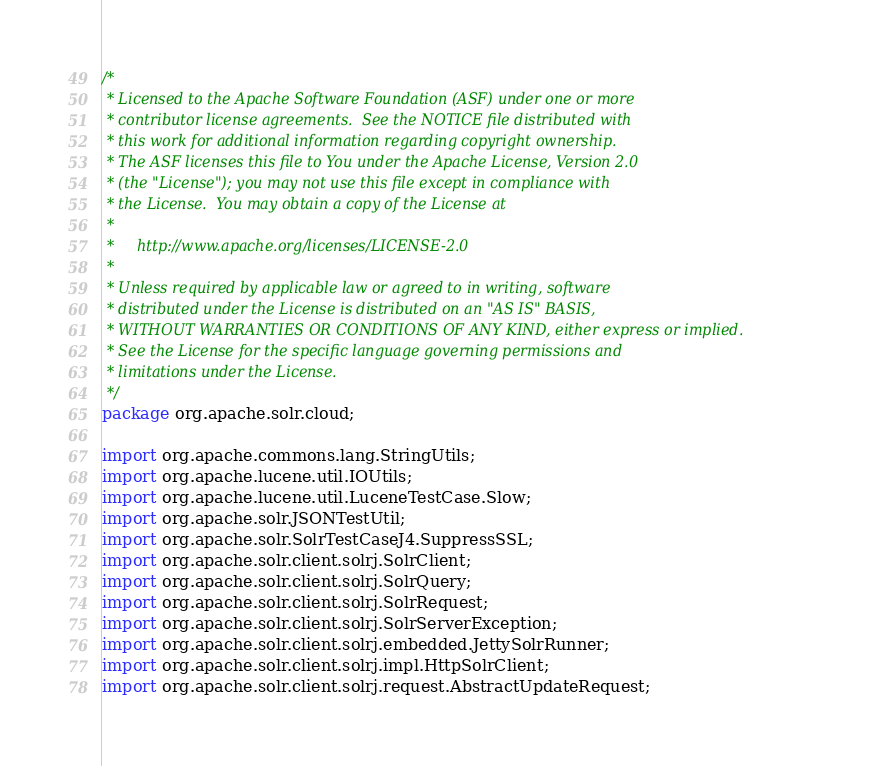<code> <loc_0><loc_0><loc_500><loc_500><_Java_>/*
 * Licensed to the Apache Software Foundation (ASF) under one or more
 * contributor license agreements.  See the NOTICE file distributed with
 * this work for additional information regarding copyright ownership.
 * The ASF licenses this file to You under the Apache License, Version 2.0
 * (the "License"); you may not use this file except in compliance with
 * the License.  You may obtain a copy of the License at
 *
 *     http://www.apache.org/licenses/LICENSE-2.0
 *
 * Unless required by applicable law or agreed to in writing, software
 * distributed under the License is distributed on an "AS IS" BASIS,
 * WITHOUT WARRANTIES OR CONDITIONS OF ANY KIND, either express or implied.
 * See the License for the specific language governing permissions and
 * limitations under the License.
 */
package org.apache.solr.cloud;

import org.apache.commons.lang.StringUtils;
import org.apache.lucene.util.IOUtils;
import org.apache.lucene.util.LuceneTestCase.Slow;
import org.apache.solr.JSONTestUtil;
import org.apache.solr.SolrTestCaseJ4.SuppressSSL;
import org.apache.solr.client.solrj.SolrClient;
import org.apache.solr.client.solrj.SolrQuery;
import org.apache.solr.client.solrj.SolrRequest;
import org.apache.solr.client.solrj.SolrServerException;
import org.apache.solr.client.solrj.embedded.JettySolrRunner;
import org.apache.solr.client.solrj.impl.HttpSolrClient;
import org.apache.solr.client.solrj.request.AbstractUpdateRequest;</code> 